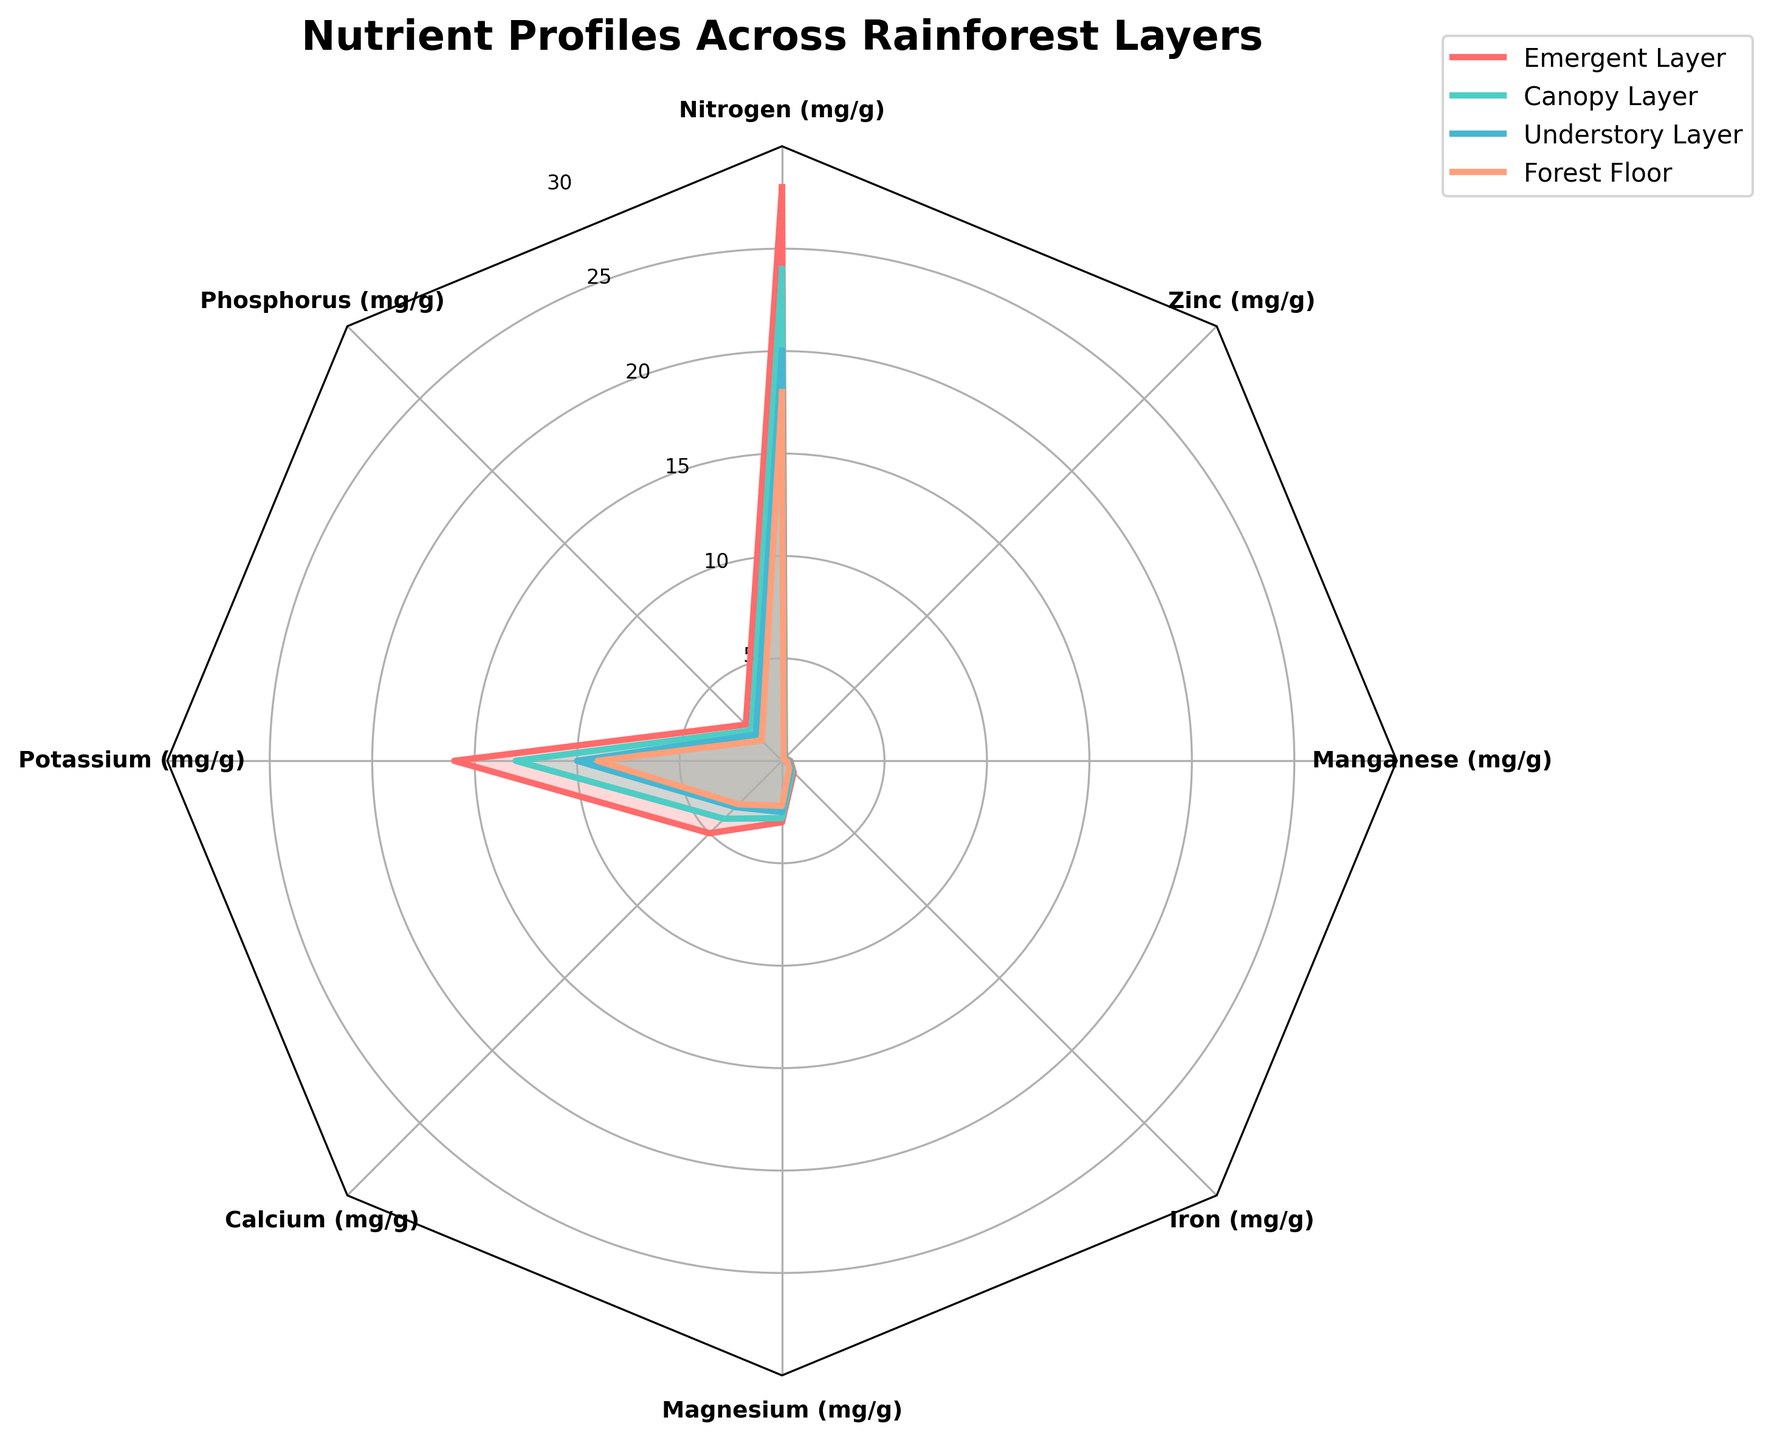Which nutrient has the highest average concentration across all layers? Calculate the average concentration for each nutrient: 
- Nitrogen: (28 + 24 + 20 + 18) / 4 = 22.5
- Phosphorus: (2.5 + 2.1 + 1.8 + 1.4) / 4 = 1.95
- Potassium: (16 + 13 + 10 + 9) / 4 = 12
- Calcium: (5 + 4 + 3.2 + 3) / 4 = 3.8
- Magnesium: (3 + 2.8 + 2.5 + 2.2) / 4 = 2.625
- Iron: (0.8 + 0.7 + 0.6 + 0.5) / 4 = 0.65
- Manganese: (0.4 + 0.35 + 0.3 + 0.25) / 4 = 0.325
- Zinc: (0.2 + 0.18 + 0.15 + 0.12) / 4 = 0.1625
The highest average concentration is for Nitrogen, which is 22.5 mg/g.
Answer: Nitrogen Which layer has the highest concentration of Potassium? Find the Potassium concentration in each layer from the data: 
- Emergent Layer: 16 mg/g
- Canopy Layer: 13 mg/g
- Understory Layer: 10 mg/g
- Forest Floor: 9 mg/g
The Emergent Layer has the highest concentration of Potassium with 16 mg/g.
Answer: Emergent Layer How does the concentration of Iron in the Forest Floor compare to the Understory Layer? Find the Iron concentration values:
- Forest Floor: 0.5 mg/g
- Understory Layer: 0.6 mg/g
Since 0.5 mg/g (Forest Floor) is less than 0.6 mg/g (Understory Layer), the concentration is lower in the Forest Floor.
Answer: Lower What is the sum of the Calcium concentrations in the Canopy and Understory Layers? Find the Calcium concentration values and add them:
- Canopy Layer: 4 mg/g
- Understory Layer: 3.2 mg/g
Sum: 4 + 3.2 = 7.2 mg/g.
Answer: 7.2 mg/g Which nutrient shows the smallest variance across the layers? Calculate the variance for each nutrient:
- Nitrogen: ((28-22.5)^2 + (24-22.5)^2 + (20-22.5)^2 + (18-22.5)^2) / 4 = 15.25
- Phosphorus: ((2.5-1.95)^2 + (2.1-1.95)^2 + (1.8-1.95)^2 + (1.4-1.95)^2) / 4 = 0.205
- Potassium: ((16-12)^2 + (13-12)^2 + (10-12)^2 + (9-12)^2) / 4 = 8.5
- Calcium: ((5-3.8)^2 + (4-3.8)^2 + (3.2-3.8)^2 + (3-3.8)^2) / 4 = 0.88
- Magnesium: ((3-2.625)^2 + (2.8-2.625)^2 + (2.5-2.625)^2 + (2.2-2.625)^2) / 4 = 0.15
- Iron: ((0.8-0.65)^2 + (0.7-0.65)^2 + (0.6-0.65)^2 + (0.5-0.65)^2) / 4 = 0.0125
- Manganese: ((0.4-0.325)^2 + (0.35-0.325)^2 + (0.3-0.325)^2 + (0.25-0.325)^2) / 4 = 0.00375
- Zinc: ((0.2-0.1625)^2 + (0.18-0.1625)^2 + (0.15-0.1625)^2 + (0.12-0.1625)^2) / 4 = 0.00094
The smallest variance is for Zinc.
Answer: Zinc Does the emergent layer generally have higher nutrient concentrations compared to the forest floor? Compare the nutrient concentrations between the Emergent Layer and Forest Floor for each:
- Nitrogen: 28 vs 18, higher
- Phosphorus: 2.5 vs 1.4, higher
- Potassium: 16 vs 9, higher
- Calcium: 5 vs 3, higher
- Magnesium: 3 vs 2.2, higher
- Iron: 0.8 vs 0.5, higher
- Manganese: 0.4 vs 0.25, higher
- Zinc: 0.2 vs .12, higher
Emergent Layer has higher concentrations in all nutrients compared to the Forest Floor.
Answer: Yes, generally higher What is the mean concentration of Magnesium across all layers? Calculate the mean concentration for Magnesium:
- Magnesium: (3 + 2.8 + 2.5 + 2.2) / 4 = 2.625 mg/g
Answer: 2.625 mg/g 